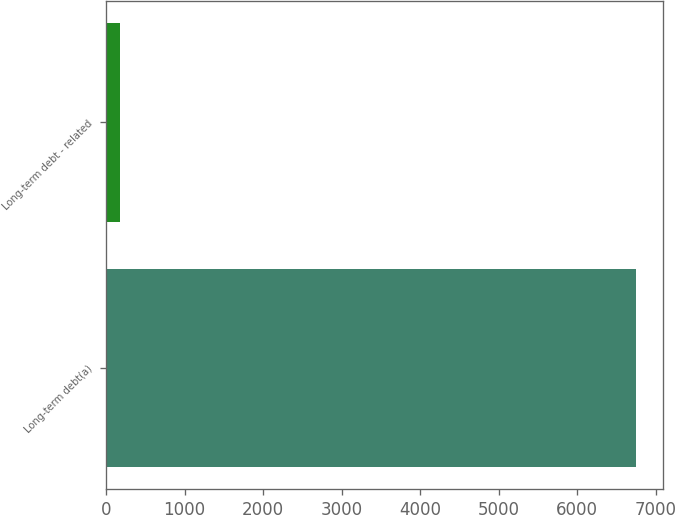Convert chart. <chart><loc_0><loc_0><loc_500><loc_500><bar_chart><fcel>Long-term debt(a)<fcel>Long-term debt - related<nl><fcel>6750<fcel>178<nl></chart> 